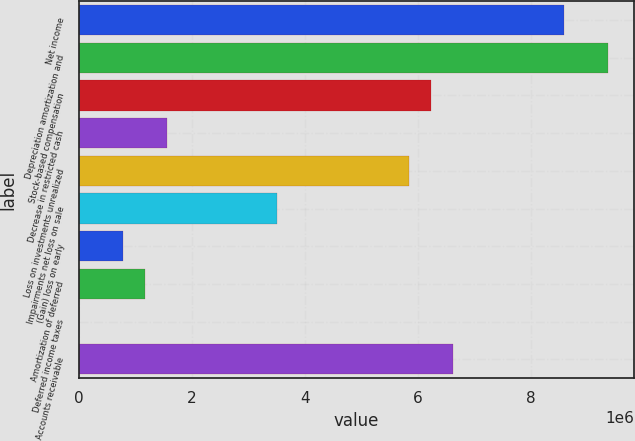Convert chart to OTSL. <chart><loc_0><loc_0><loc_500><loc_500><bar_chart><fcel>Net income<fcel>Depreciation amortization and<fcel>Stock-based compensation<fcel>Decrease in restricted cash<fcel>Loss on investments unrealized<fcel>Impairments net loss on sale<fcel>(Gain) loss on early<fcel>Amortization of deferred<fcel>Deferred income taxes<fcel>Accounts receivable<nl><fcel>8.58526e+06<fcel>9.36561e+06<fcel>6.2442e+06<fcel>1.56209e+06<fcel>5.85402e+06<fcel>3.51297e+06<fcel>781736<fcel>1.17191e+06<fcel>1384<fcel>6.63438e+06<nl></chart> 